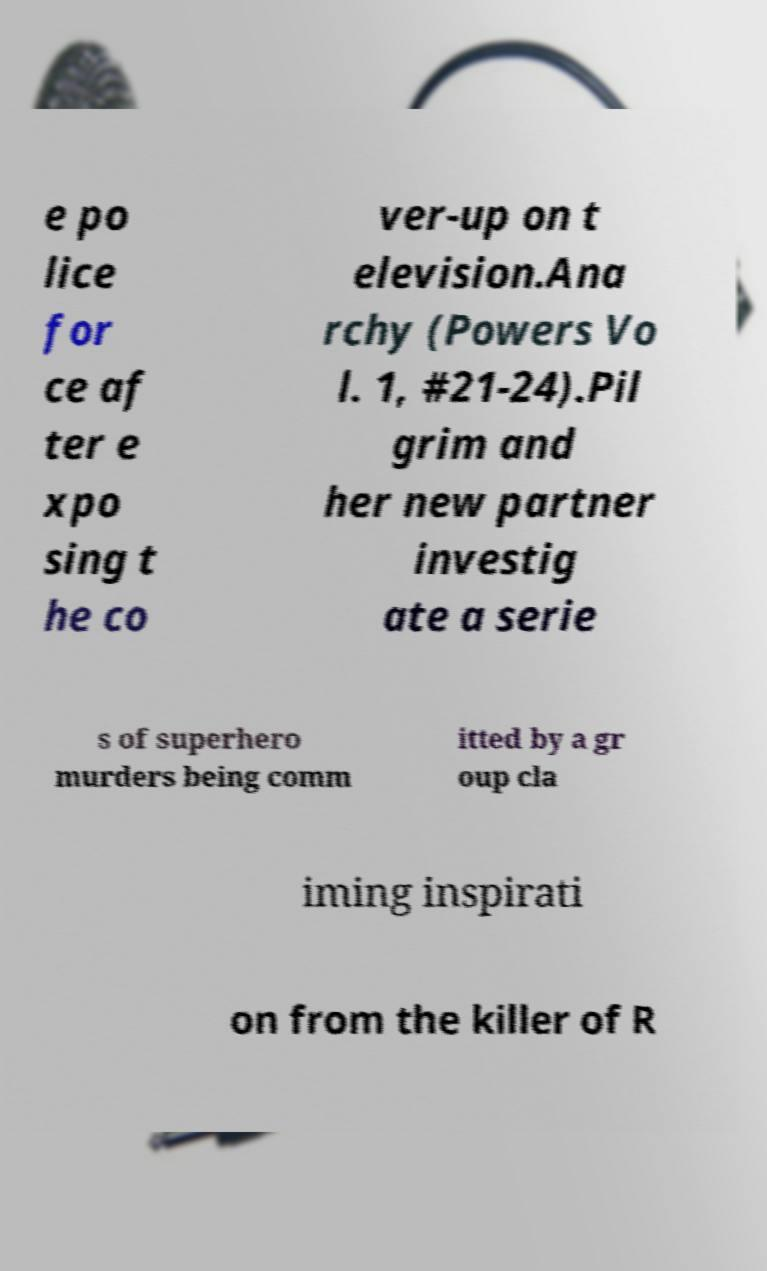Please read and relay the text visible in this image. What does it say? e po lice for ce af ter e xpo sing t he co ver-up on t elevision.Ana rchy (Powers Vo l. 1, #21-24).Pil grim and her new partner investig ate a serie s of superhero murders being comm itted by a gr oup cla iming inspirati on from the killer of R 